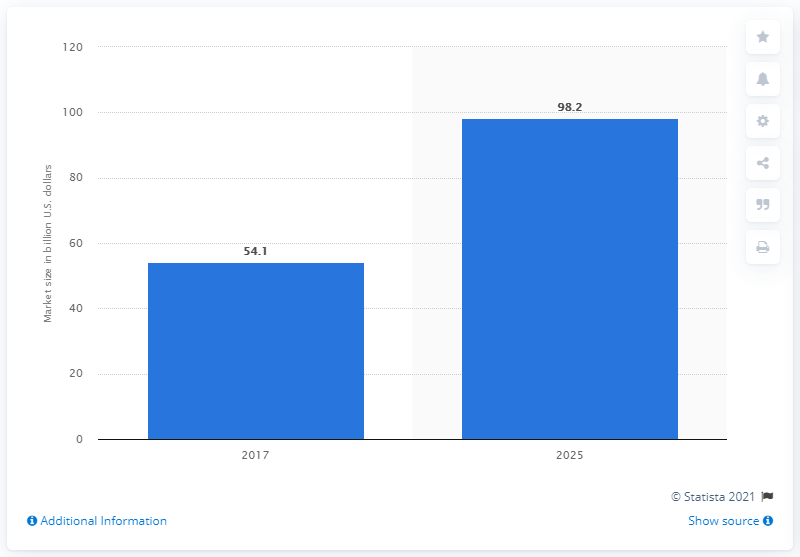Identify some key points in this picture. I have determined that the forecast for the global metastatic cancer treatment market is for the year 2025. In 2017, the global market for metastatic cancer treatment was valued at 54.1... 